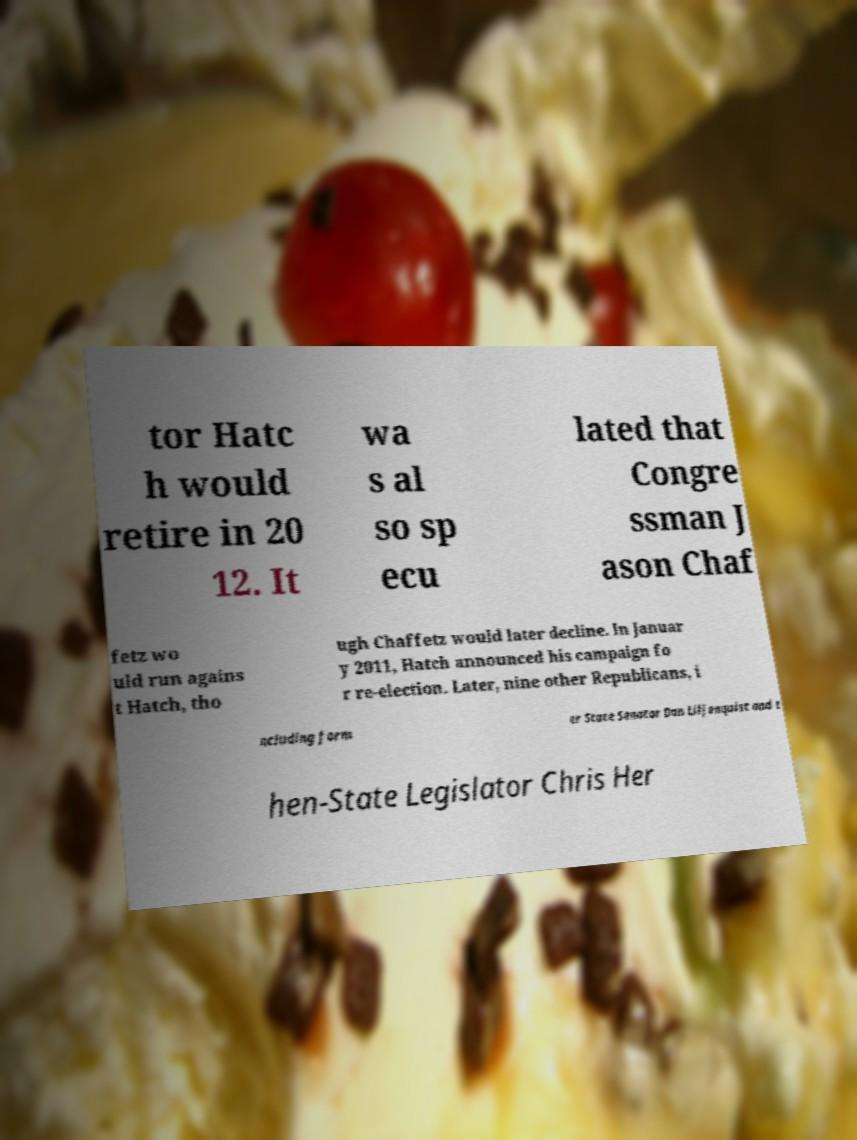For documentation purposes, I need the text within this image transcribed. Could you provide that? tor Hatc h would retire in 20 12. It wa s al so sp ecu lated that Congre ssman J ason Chaf fetz wo uld run agains t Hatch, tho ugh Chaffetz would later decline. In Januar y 2011, Hatch announced his campaign fo r re-election. Later, nine other Republicans, i ncluding form er State Senator Dan Liljenquist and t hen-State Legislator Chris Her 